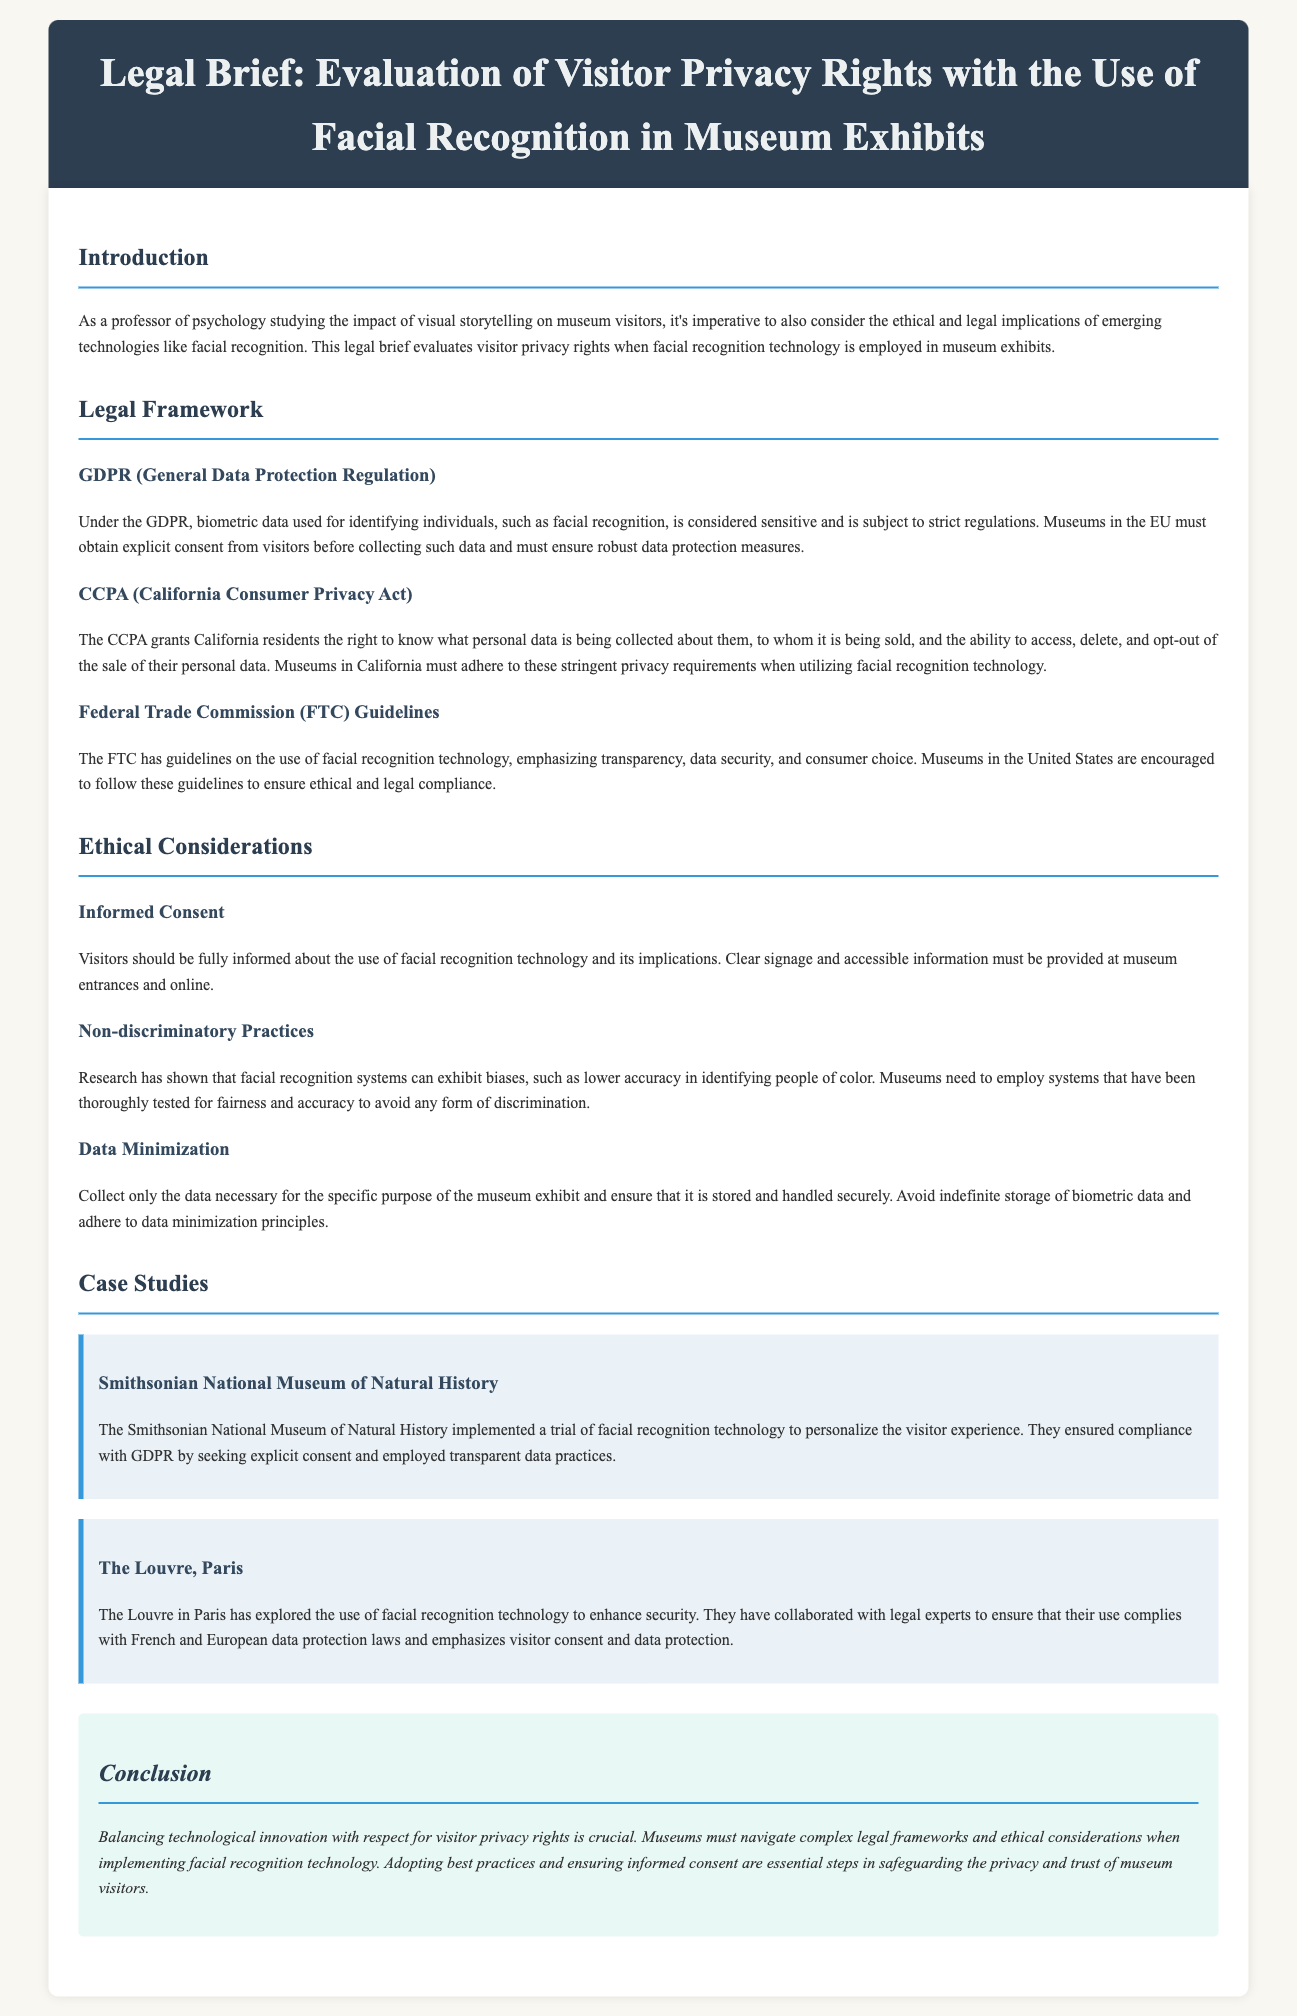What is the primary focus of this legal brief? The legal brief primarily focuses on the evaluation of visitor privacy rights in the context of facial recognition usage in museums.
Answer: Evaluation of visitor privacy rights What does GDPR stand for? GDPR is an abbreviation used in the document that refers to a specific regulation regarding the collection of biometric data.
Answer: General Data Protection Regulation Which museum is mentioned in the document as implementing facial recognition? The document discusses a specific museum that trialed facial recognition technology to enhance visitor experience.
Answer: Smithsonian National Museum of Natural History What is a key ethical consideration regarding the use of facial recognition? This consideration is outlined in the ethical considerations section, focusing on visitor awareness and consent related to facial recognition technology.
Answer: Informed Consent What legal framework applies to museums in California? This framework addresses the collection of personal data and rights of consumers regarding their data.
Answer: CCPA How must museums ensure compliance when using facial recognition technology? This involves adhering to various guidelines which emphasize transparency and security concerning data collection practices.
Answer: Follow FTC guidelines What bias is highlighted concerning facial recognition technology? The document mentions a particular group that facial recognition technology has been shown to inaccurately identify.
Answer: People of color What is the concluding emphasis of this legal brief? The conclusion underscores a balance that must be maintained between technological innovation and visitor privacy rights in museums.
Answer: Balancing technological innovation with respect for visitor privacy rights 